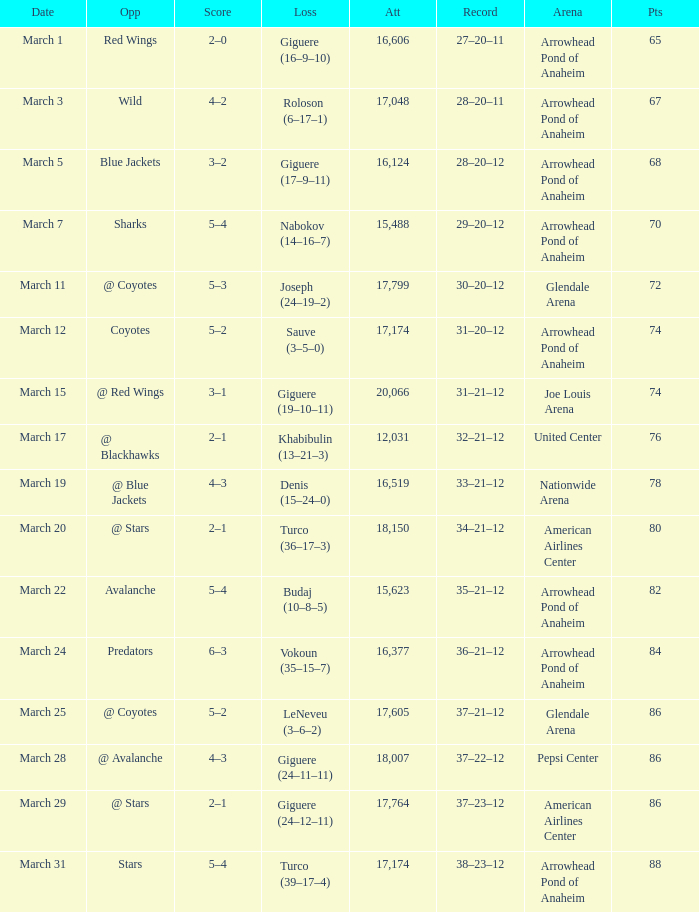What is the number of attendees for the game having a 37-21-12 record and fewer than 86 points? None. 